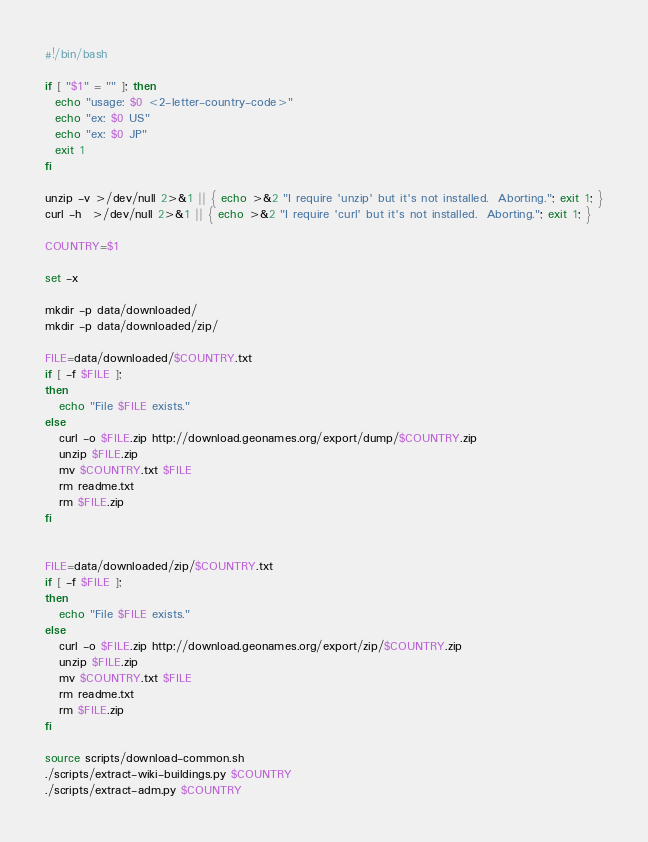Convert code to text. <code><loc_0><loc_0><loc_500><loc_500><_Bash_>#!/bin/bash

if [ "$1" = "" ]; then
  echo "usage: $0 <2-letter-country-code>"
  echo "ex: $0 US"
  echo "ex: $0 JP"
  exit 1
fi

unzip -v >/dev/null 2>&1 || { echo >&2 "I require 'unzip' but it's not installed.  Aborting."; exit 1; }
curl -h  >/dev/null 2>&1 || { echo >&2 "I require 'curl' but it's not installed.  Aborting."; exit 1; }

COUNTRY=$1

set -x

mkdir -p data/downloaded/
mkdir -p data/downloaded/zip/

FILE=data/downloaded/$COUNTRY.txt
if [ -f $FILE ];
then
   echo "File $FILE exists."
else
   curl -o $FILE.zip http://download.geonames.org/export/dump/$COUNTRY.zip
   unzip $FILE.zip
   mv $COUNTRY.txt $FILE
   rm readme.txt
   rm $FILE.zip
fi


FILE=data/downloaded/zip/$COUNTRY.txt
if [ -f $FILE ];
then
   echo "File $FILE exists."
else
   curl -o $FILE.zip http://download.geonames.org/export/zip/$COUNTRY.zip
   unzip $FILE.zip
   mv $COUNTRY.txt $FILE
   rm readme.txt
   rm $FILE.zip
fi

source scripts/download-common.sh
./scripts/extract-wiki-buildings.py $COUNTRY
./scripts/extract-adm.py $COUNTRY
</code> 